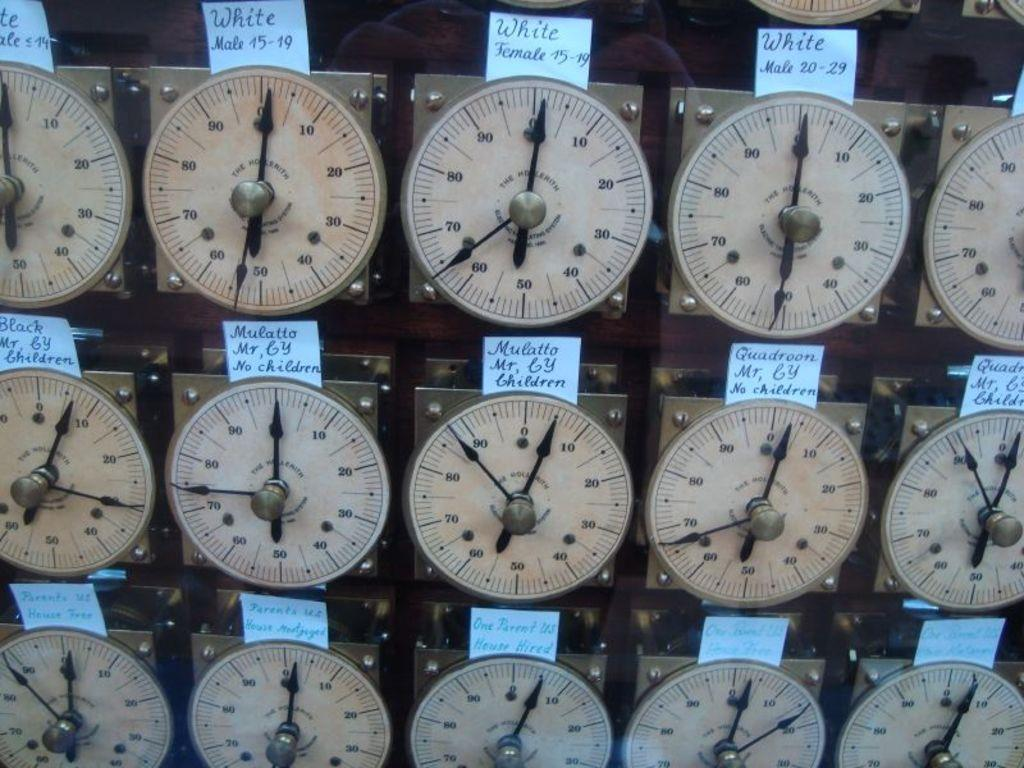<image>
Relay a brief, clear account of the picture shown. A group of watch faces have paper labels that include Mulatto and White. 